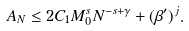<formula> <loc_0><loc_0><loc_500><loc_500>A _ { N } \leq 2 C _ { 1 } M _ { 0 } ^ { s } N ^ { - s + \gamma } + ( \beta ^ { \prime } ) ^ { j } .</formula> 